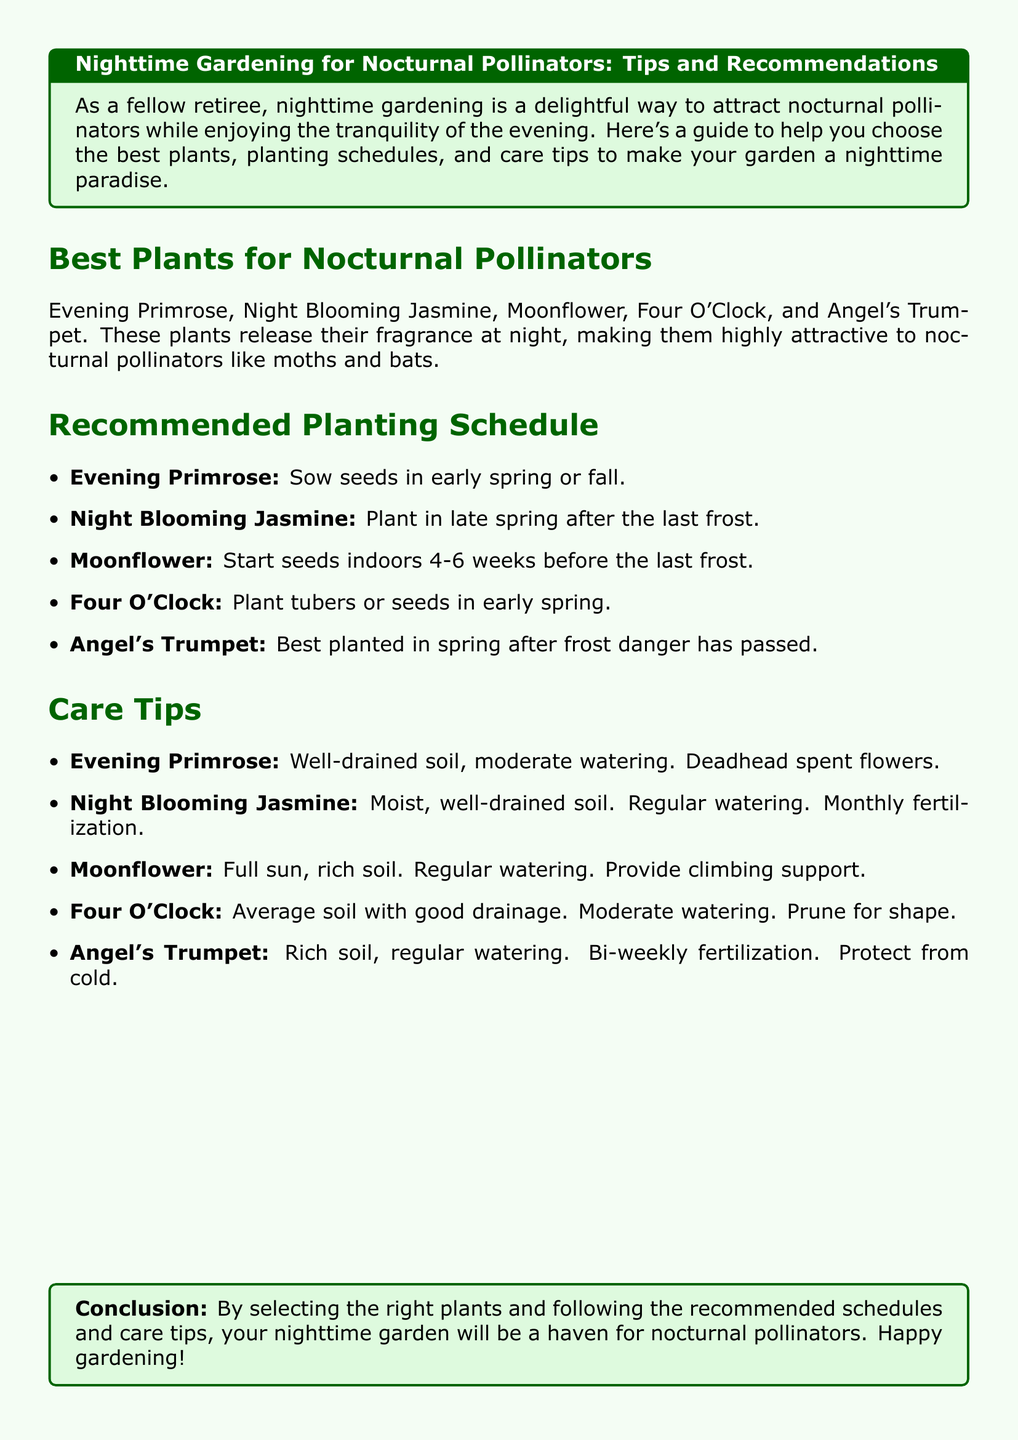What plants attract nocturnal pollinators? The document lists specific plants that attract nocturnal pollinators, which are Evening Primrose, Night Blooming Jasmine, Moonflower, Four O'Clock, and Angel's Trumpet.
Answer: Evening Primrose, Night Blooming Jasmine, Moonflower, Four O'Clock, Angel's Trumpet When should you sow Evening Primrose seeds? The document states the recommended planting schedule for Evening Primrose, indicating early spring or fall.
Answer: Early spring or fall What soil condition is best for Night Blooming Jasmine? The care tips for Night Blooming Jasmine specify the need for moist, well-drained soil.
Answer: Moist, well-drained soil Which plant needs climbing support? The document indicates that Moonflower requires climbing support as part of its care.
Answer: Moonflower How often should Angel's Trumpet be fertilized? The care tips suggest that Angel's Trumpet should be fertilized bi-weekly.
Answer: Bi-weekly 